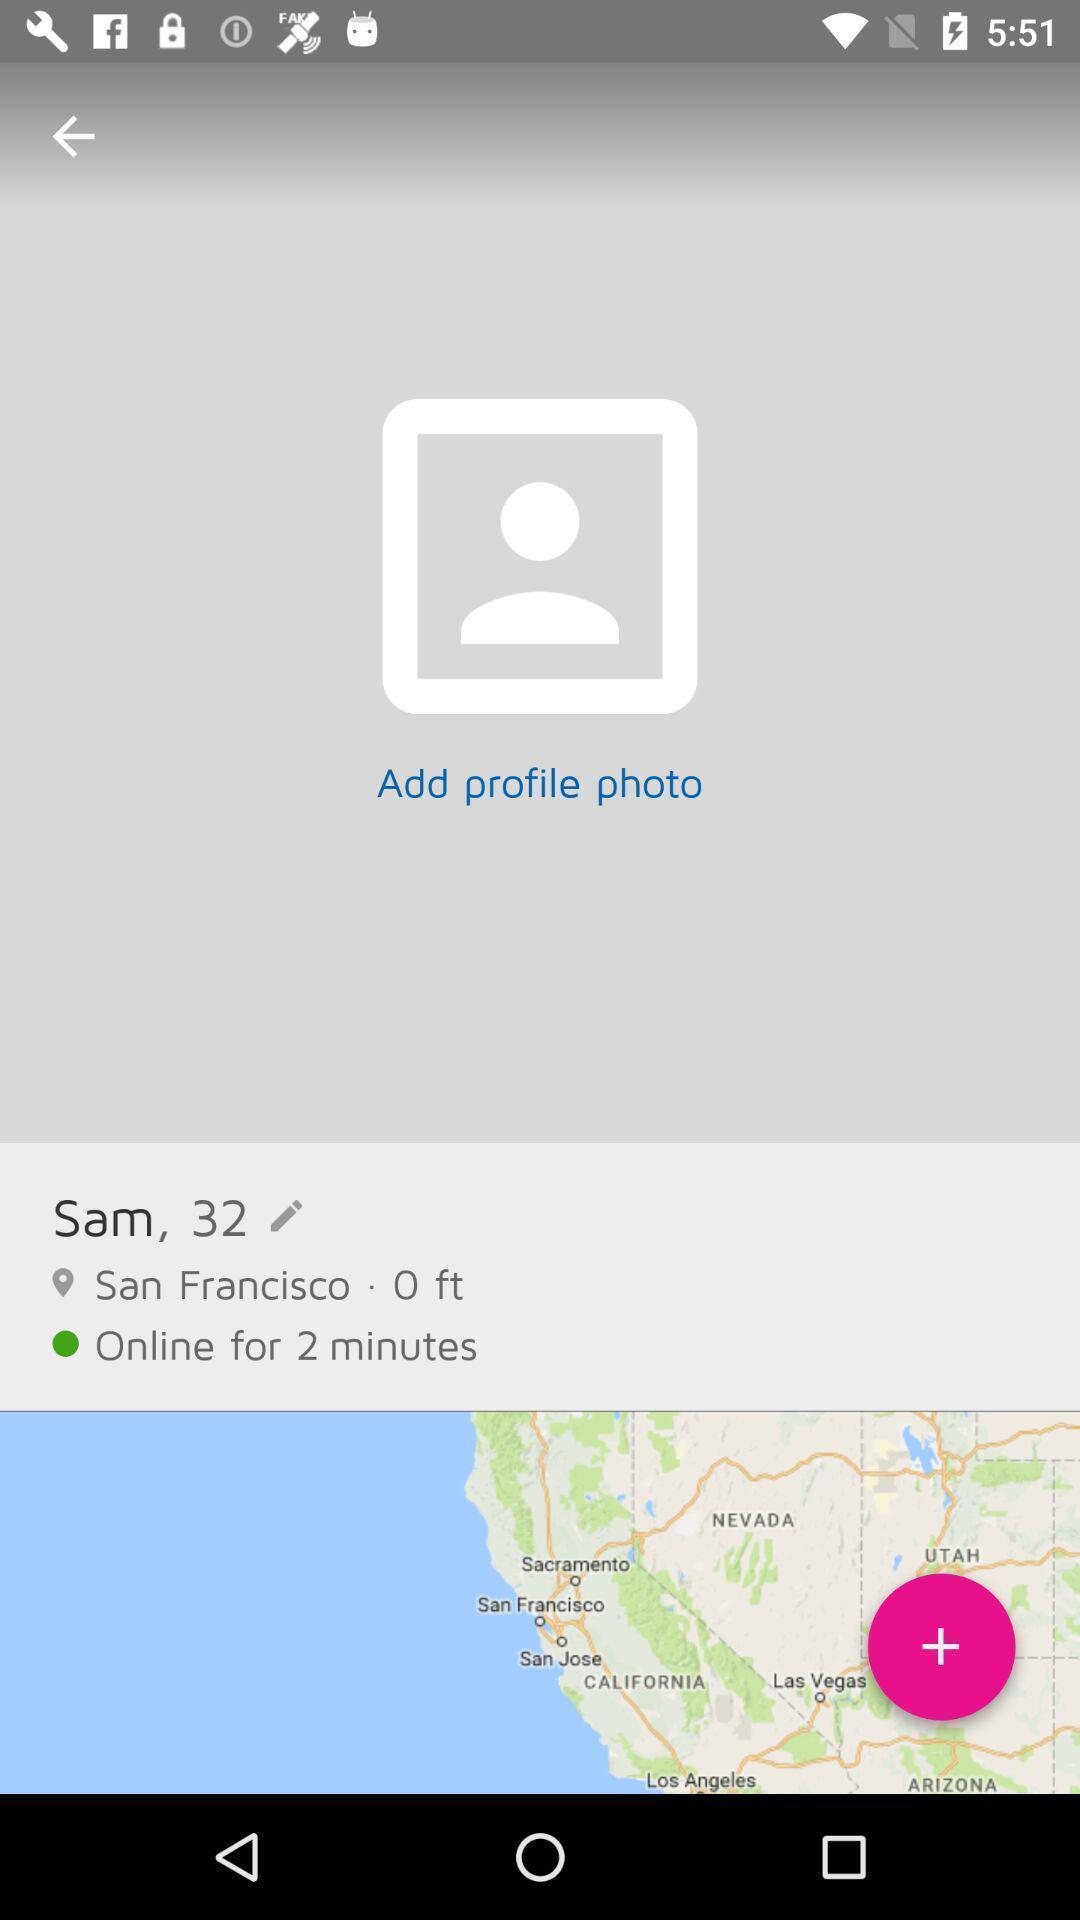Provide a textual representation of this image. Page to add profile photo. 